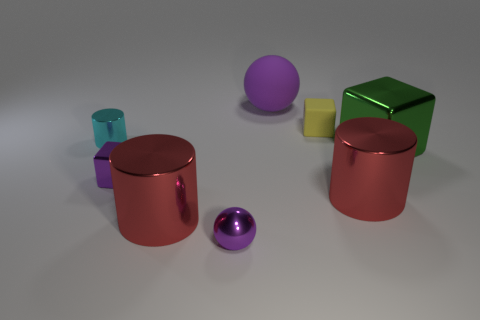What's the texture of the objects look like? The objects have a reflective, metallic finish, displaying shiny surfaces that reflect their surroundings to some extent. The lighting in the scene enhances the glossiness of their textures.  Are there any objects that share a similar color? Yes, the two spherical objects share a similar shade of purple, although their sizes are different with one being larger than the other. 